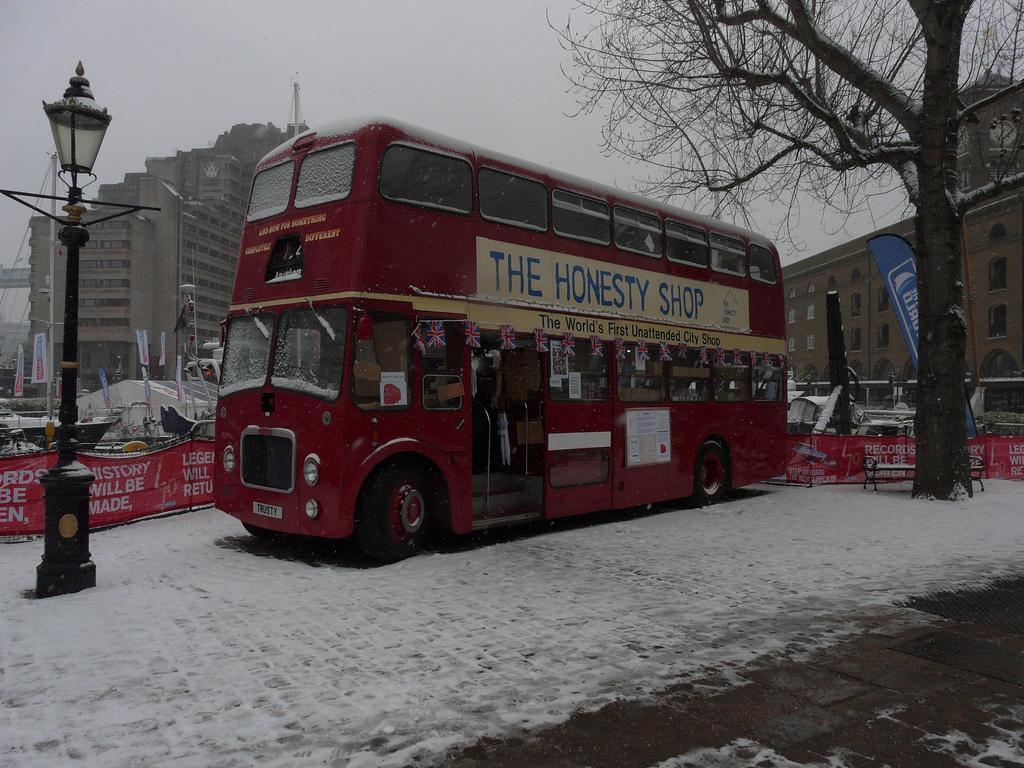How many levels is the bus?
Give a very brief answer. 2. How many levels does this bus have?
Give a very brief answer. 2. How many windows are visible on the upper deck?
Give a very brief answer. 9. How many doors are open?
Give a very brief answer. 1. 